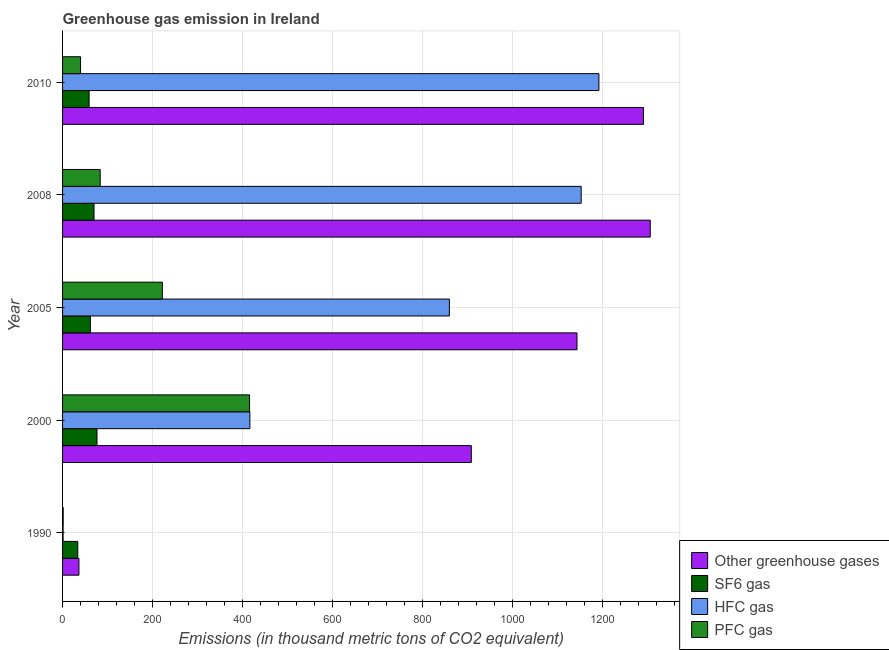How many groups of bars are there?
Your response must be concise. 5. How many bars are there on the 4th tick from the bottom?
Ensure brevity in your answer.  4. In how many cases, is the number of bars for a given year not equal to the number of legend labels?
Ensure brevity in your answer.  0. What is the emission of greenhouse gases in 2005?
Provide a short and direct response. 1143.3. Across all years, what is the maximum emission of greenhouse gases?
Keep it short and to the point. 1306.1. What is the total emission of greenhouse gases in the graph?
Your response must be concise. 4685.2. What is the difference between the emission of greenhouse gases in 2000 and that in 2010?
Provide a succinct answer. -382.6. What is the difference between the emission of hfc gas in 2010 and the emission of sf6 gas in 1990?
Offer a very short reply. 1158.2. What is the average emission of sf6 gas per year?
Keep it short and to the point. 60.2. In the year 2000, what is the difference between the emission of hfc gas and emission of greenhouse gases?
Your answer should be very brief. -492.1. In how many years, is the emission of pfc gas greater than 240 thousand metric tons?
Your answer should be compact. 1. What is the ratio of the emission of sf6 gas in 1990 to that in 2008?
Ensure brevity in your answer.  0.48. Is the emission of greenhouse gases in 1990 less than that in 2000?
Offer a very short reply. Yes. Is the difference between the emission of pfc gas in 2000 and 2010 greater than the difference between the emission of sf6 gas in 2000 and 2010?
Offer a very short reply. Yes. What is the difference between the highest and the lowest emission of sf6 gas?
Keep it short and to the point. 42.7. Is it the case that in every year, the sum of the emission of pfc gas and emission of hfc gas is greater than the sum of emission of sf6 gas and emission of greenhouse gases?
Your answer should be compact. No. What does the 2nd bar from the top in 1990 represents?
Provide a short and direct response. HFC gas. What does the 4th bar from the bottom in 2010 represents?
Ensure brevity in your answer.  PFC gas. How many years are there in the graph?
Make the answer very short. 5. Are the values on the major ticks of X-axis written in scientific E-notation?
Give a very brief answer. No. Where does the legend appear in the graph?
Give a very brief answer. Bottom right. How many legend labels are there?
Keep it short and to the point. 4. How are the legend labels stacked?
Make the answer very short. Vertical. What is the title of the graph?
Provide a short and direct response. Greenhouse gas emission in Ireland. What is the label or title of the X-axis?
Ensure brevity in your answer.  Emissions (in thousand metric tons of CO2 equivalent). What is the label or title of the Y-axis?
Offer a terse response. Year. What is the Emissions (in thousand metric tons of CO2 equivalent) in Other greenhouse gases in 1990?
Provide a succinct answer. 36.4. What is the Emissions (in thousand metric tons of CO2 equivalent) in SF6 gas in 1990?
Provide a short and direct response. 33.8. What is the Emissions (in thousand metric tons of CO2 equivalent) of Other greenhouse gases in 2000?
Provide a succinct answer. 908.4. What is the Emissions (in thousand metric tons of CO2 equivalent) of SF6 gas in 2000?
Provide a short and direct response. 76.5. What is the Emissions (in thousand metric tons of CO2 equivalent) of HFC gas in 2000?
Your answer should be compact. 416.3. What is the Emissions (in thousand metric tons of CO2 equivalent) in PFC gas in 2000?
Provide a succinct answer. 415.6. What is the Emissions (in thousand metric tons of CO2 equivalent) of Other greenhouse gases in 2005?
Keep it short and to the point. 1143.3. What is the Emissions (in thousand metric tons of CO2 equivalent) in SF6 gas in 2005?
Provide a succinct answer. 61.8. What is the Emissions (in thousand metric tons of CO2 equivalent) of HFC gas in 2005?
Your response must be concise. 859.7. What is the Emissions (in thousand metric tons of CO2 equivalent) of PFC gas in 2005?
Offer a very short reply. 221.8. What is the Emissions (in thousand metric tons of CO2 equivalent) in Other greenhouse gases in 2008?
Offer a very short reply. 1306.1. What is the Emissions (in thousand metric tons of CO2 equivalent) of SF6 gas in 2008?
Your answer should be compact. 69.9. What is the Emissions (in thousand metric tons of CO2 equivalent) of HFC gas in 2008?
Offer a very short reply. 1152.6. What is the Emissions (in thousand metric tons of CO2 equivalent) in PFC gas in 2008?
Offer a very short reply. 83.6. What is the Emissions (in thousand metric tons of CO2 equivalent) in Other greenhouse gases in 2010?
Your answer should be compact. 1291. What is the Emissions (in thousand metric tons of CO2 equivalent) in HFC gas in 2010?
Offer a terse response. 1192. Across all years, what is the maximum Emissions (in thousand metric tons of CO2 equivalent) of Other greenhouse gases?
Keep it short and to the point. 1306.1. Across all years, what is the maximum Emissions (in thousand metric tons of CO2 equivalent) in SF6 gas?
Ensure brevity in your answer.  76.5. Across all years, what is the maximum Emissions (in thousand metric tons of CO2 equivalent) of HFC gas?
Keep it short and to the point. 1192. Across all years, what is the maximum Emissions (in thousand metric tons of CO2 equivalent) in PFC gas?
Make the answer very short. 415.6. Across all years, what is the minimum Emissions (in thousand metric tons of CO2 equivalent) in Other greenhouse gases?
Your response must be concise. 36.4. Across all years, what is the minimum Emissions (in thousand metric tons of CO2 equivalent) of SF6 gas?
Your answer should be compact. 33.8. Across all years, what is the minimum Emissions (in thousand metric tons of CO2 equivalent) of HFC gas?
Make the answer very short. 1.2. Across all years, what is the minimum Emissions (in thousand metric tons of CO2 equivalent) in PFC gas?
Provide a short and direct response. 1.4. What is the total Emissions (in thousand metric tons of CO2 equivalent) of Other greenhouse gases in the graph?
Give a very brief answer. 4685.2. What is the total Emissions (in thousand metric tons of CO2 equivalent) of SF6 gas in the graph?
Your response must be concise. 301. What is the total Emissions (in thousand metric tons of CO2 equivalent) in HFC gas in the graph?
Provide a short and direct response. 3621.8. What is the total Emissions (in thousand metric tons of CO2 equivalent) in PFC gas in the graph?
Ensure brevity in your answer.  762.4. What is the difference between the Emissions (in thousand metric tons of CO2 equivalent) of Other greenhouse gases in 1990 and that in 2000?
Your answer should be compact. -872. What is the difference between the Emissions (in thousand metric tons of CO2 equivalent) of SF6 gas in 1990 and that in 2000?
Your response must be concise. -42.7. What is the difference between the Emissions (in thousand metric tons of CO2 equivalent) in HFC gas in 1990 and that in 2000?
Offer a terse response. -415.1. What is the difference between the Emissions (in thousand metric tons of CO2 equivalent) in PFC gas in 1990 and that in 2000?
Offer a terse response. -414.2. What is the difference between the Emissions (in thousand metric tons of CO2 equivalent) in Other greenhouse gases in 1990 and that in 2005?
Offer a very short reply. -1106.9. What is the difference between the Emissions (in thousand metric tons of CO2 equivalent) in SF6 gas in 1990 and that in 2005?
Ensure brevity in your answer.  -28. What is the difference between the Emissions (in thousand metric tons of CO2 equivalent) of HFC gas in 1990 and that in 2005?
Make the answer very short. -858.5. What is the difference between the Emissions (in thousand metric tons of CO2 equivalent) in PFC gas in 1990 and that in 2005?
Your answer should be compact. -220.4. What is the difference between the Emissions (in thousand metric tons of CO2 equivalent) in Other greenhouse gases in 1990 and that in 2008?
Offer a very short reply. -1269.7. What is the difference between the Emissions (in thousand metric tons of CO2 equivalent) in SF6 gas in 1990 and that in 2008?
Keep it short and to the point. -36.1. What is the difference between the Emissions (in thousand metric tons of CO2 equivalent) in HFC gas in 1990 and that in 2008?
Your response must be concise. -1151.4. What is the difference between the Emissions (in thousand metric tons of CO2 equivalent) of PFC gas in 1990 and that in 2008?
Give a very brief answer. -82.2. What is the difference between the Emissions (in thousand metric tons of CO2 equivalent) of Other greenhouse gases in 1990 and that in 2010?
Your answer should be very brief. -1254.6. What is the difference between the Emissions (in thousand metric tons of CO2 equivalent) in SF6 gas in 1990 and that in 2010?
Your answer should be compact. -25.2. What is the difference between the Emissions (in thousand metric tons of CO2 equivalent) in HFC gas in 1990 and that in 2010?
Offer a terse response. -1190.8. What is the difference between the Emissions (in thousand metric tons of CO2 equivalent) of PFC gas in 1990 and that in 2010?
Give a very brief answer. -38.6. What is the difference between the Emissions (in thousand metric tons of CO2 equivalent) in Other greenhouse gases in 2000 and that in 2005?
Provide a short and direct response. -234.9. What is the difference between the Emissions (in thousand metric tons of CO2 equivalent) in SF6 gas in 2000 and that in 2005?
Keep it short and to the point. 14.7. What is the difference between the Emissions (in thousand metric tons of CO2 equivalent) of HFC gas in 2000 and that in 2005?
Provide a succinct answer. -443.4. What is the difference between the Emissions (in thousand metric tons of CO2 equivalent) of PFC gas in 2000 and that in 2005?
Your answer should be very brief. 193.8. What is the difference between the Emissions (in thousand metric tons of CO2 equivalent) of Other greenhouse gases in 2000 and that in 2008?
Offer a very short reply. -397.7. What is the difference between the Emissions (in thousand metric tons of CO2 equivalent) in HFC gas in 2000 and that in 2008?
Provide a short and direct response. -736.3. What is the difference between the Emissions (in thousand metric tons of CO2 equivalent) in PFC gas in 2000 and that in 2008?
Offer a very short reply. 332. What is the difference between the Emissions (in thousand metric tons of CO2 equivalent) in Other greenhouse gases in 2000 and that in 2010?
Offer a terse response. -382.6. What is the difference between the Emissions (in thousand metric tons of CO2 equivalent) of SF6 gas in 2000 and that in 2010?
Provide a short and direct response. 17.5. What is the difference between the Emissions (in thousand metric tons of CO2 equivalent) of HFC gas in 2000 and that in 2010?
Keep it short and to the point. -775.7. What is the difference between the Emissions (in thousand metric tons of CO2 equivalent) of PFC gas in 2000 and that in 2010?
Provide a short and direct response. 375.6. What is the difference between the Emissions (in thousand metric tons of CO2 equivalent) in Other greenhouse gases in 2005 and that in 2008?
Your answer should be very brief. -162.8. What is the difference between the Emissions (in thousand metric tons of CO2 equivalent) in SF6 gas in 2005 and that in 2008?
Keep it short and to the point. -8.1. What is the difference between the Emissions (in thousand metric tons of CO2 equivalent) of HFC gas in 2005 and that in 2008?
Offer a terse response. -292.9. What is the difference between the Emissions (in thousand metric tons of CO2 equivalent) of PFC gas in 2005 and that in 2008?
Provide a short and direct response. 138.2. What is the difference between the Emissions (in thousand metric tons of CO2 equivalent) of Other greenhouse gases in 2005 and that in 2010?
Offer a very short reply. -147.7. What is the difference between the Emissions (in thousand metric tons of CO2 equivalent) in SF6 gas in 2005 and that in 2010?
Your response must be concise. 2.8. What is the difference between the Emissions (in thousand metric tons of CO2 equivalent) in HFC gas in 2005 and that in 2010?
Your answer should be very brief. -332.3. What is the difference between the Emissions (in thousand metric tons of CO2 equivalent) in PFC gas in 2005 and that in 2010?
Keep it short and to the point. 181.8. What is the difference between the Emissions (in thousand metric tons of CO2 equivalent) in HFC gas in 2008 and that in 2010?
Provide a succinct answer. -39.4. What is the difference between the Emissions (in thousand metric tons of CO2 equivalent) in PFC gas in 2008 and that in 2010?
Offer a terse response. 43.6. What is the difference between the Emissions (in thousand metric tons of CO2 equivalent) in Other greenhouse gases in 1990 and the Emissions (in thousand metric tons of CO2 equivalent) in SF6 gas in 2000?
Ensure brevity in your answer.  -40.1. What is the difference between the Emissions (in thousand metric tons of CO2 equivalent) in Other greenhouse gases in 1990 and the Emissions (in thousand metric tons of CO2 equivalent) in HFC gas in 2000?
Your answer should be very brief. -379.9. What is the difference between the Emissions (in thousand metric tons of CO2 equivalent) of Other greenhouse gases in 1990 and the Emissions (in thousand metric tons of CO2 equivalent) of PFC gas in 2000?
Make the answer very short. -379.2. What is the difference between the Emissions (in thousand metric tons of CO2 equivalent) in SF6 gas in 1990 and the Emissions (in thousand metric tons of CO2 equivalent) in HFC gas in 2000?
Provide a succinct answer. -382.5. What is the difference between the Emissions (in thousand metric tons of CO2 equivalent) in SF6 gas in 1990 and the Emissions (in thousand metric tons of CO2 equivalent) in PFC gas in 2000?
Give a very brief answer. -381.8. What is the difference between the Emissions (in thousand metric tons of CO2 equivalent) of HFC gas in 1990 and the Emissions (in thousand metric tons of CO2 equivalent) of PFC gas in 2000?
Ensure brevity in your answer.  -414.4. What is the difference between the Emissions (in thousand metric tons of CO2 equivalent) in Other greenhouse gases in 1990 and the Emissions (in thousand metric tons of CO2 equivalent) in SF6 gas in 2005?
Keep it short and to the point. -25.4. What is the difference between the Emissions (in thousand metric tons of CO2 equivalent) in Other greenhouse gases in 1990 and the Emissions (in thousand metric tons of CO2 equivalent) in HFC gas in 2005?
Ensure brevity in your answer.  -823.3. What is the difference between the Emissions (in thousand metric tons of CO2 equivalent) in Other greenhouse gases in 1990 and the Emissions (in thousand metric tons of CO2 equivalent) in PFC gas in 2005?
Your answer should be very brief. -185.4. What is the difference between the Emissions (in thousand metric tons of CO2 equivalent) of SF6 gas in 1990 and the Emissions (in thousand metric tons of CO2 equivalent) of HFC gas in 2005?
Keep it short and to the point. -825.9. What is the difference between the Emissions (in thousand metric tons of CO2 equivalent) in SF6 gas in 1990 and the Emissions (in thousand metric tons of CO2 equivalent) in PFC gas in 2005?
Provide a short and direct response. -188. What is the difference between the Emissions (in thousand metric tons of CO2 equivalent) in HFC gas in 1990 and the Emissions (in thousand metric tons of CO2 equivalent) in PFC gas in 2005?
Give a very brief answer. -220.6. What is the difference between the Emissions (in thousand metric tons of CO2 equivalent) of Other greenhouse gases in 1990 and the Emissions (in thousand metric tons of CO2 equivalent) of SF6 gas in 2008?
Ensure brevity in your answer.  -33.5. What is the difference between the Emissions (in thousand metric tons of CO2 equivalent) in Other greenhouse gases in 1990 and the Emissions (in thousand metric tons of CO2 equivalent) in HFC gas in 2008?
Your response must be concise. -1116.2. What is the difference between the Emissions (in thousand metric tons of CO2 equivalent) in Other greenhouse gases in 1990 and the Emissions (in thousand metric tons of CO2 equivalent) in PFC gas in 2008?
Provide a short and direct response. -47.2. What is the difference between the Emissions (in thousand metric tons of CO2 equivalent) of SF6 gas in 1990 and the Emissions (in thousand metric tons of CO2 equivalent) of HFC gas in 2008?
Your answer should be compact. -1118.8. What is the difference between the Emissions (in thousand metric tons of CO2 equivalent) in SF6 gas in 1990 and the Emissions (in thousand metric tons of CO2 equivalent) in PFC gas in 2008?
Provide a succinct answer. -49.8. What is the difference between the Emissions (in thousand metric tons of CO2 equivalent) in HFC gas in 1990 and the Emissions (in thousand metric tons of CO2 equivalent) in PFC gas in 2008?
Keep it short and to the point. -82.4. What is the difference between the Emissions (in thousand metric tons of CO2 equivalent) in Other greenhouse gases in 1990 and the Emissions (in thousand metric tons of CO2 equivalent) in SF6 gas in 2010?
Give a very brief answer. -22.6. What is the difference between the Emissions (in thousand metric tons of CO2 equivalent) in Other greenhouse gases in 1990 and the Emissions (in thousand metric tons of CO2 equivalent) in HFC gas in 2010?
Your answer should be compact. -1155.6. What is the difference between the Emissions (in thousand metric tons of CO2 equivalent) in SF6 gas in 1990 and the Emissions (in thousand metric tons of CO2 equivalent) in HFC gas in 2010?
Offer a very short reply. -1158.2. What is the difference between the Emissions (in thousand metric tons of CO2 equivalent) in HFC gas in 1990 and the Emissions (in thousand metric tons of CO2 equivalent) in PFC gas in 2010?
Make the answer very short. -38.8. What is the difference between the Emissions (in thousand metric tons of CO2 equivalent) in Other greenhouse gases in 2000 and the Emissions (in thousand metric tons of CO2 equivalent) in SF6 gas in 2005?
Make the answer very short. 846.6. What is the difference between the Emissions (in thousand metric tons of CO2 equivalent) of Other greenhouse gases in 2000 and the Emissions (in thousand metric tons of CO2 equivalent) of HFC gas in 2005?
Make the answer very short. 48.7. What is the difference between the Emissions (in thousand metric tons of CO2 equivalent) of Other greenhouse gases in 2000 and the Emissions (in thousand metric tons of CO2 equivalent) of PFC gas in 2005?
Offer a very short reply. 686.6. What is the difference between the Emissions (in thousand metric tons of CO2 equivalent) of SF6 gas in 2000 and the Emissions (in thousand metric tons of CO2 equivalent) of HFC gas in 2005?
Your answer should be compact. -783.2. What is the difference between the Emissions (in thousand metric tons of CO2 equivalent) in SF6 gas in 2000 and the Emissions (in thousand metric tons of CO2 equivalent) in PFC gas in 2005?
Offer a terse response. -145.3. What is the difference between the Emissions (in thousand metric tons of CO2 equivalent) in HFC gas in 2000 and the Emissions (in thousand metric tons of CO2 equivalent) in PFC gas in 2005?
Your answer should be compact. 194.5. What is the difference between the Emissions (in thousand metric tons of CO2 equivalent) of Other greenhouse gases in 2000 and the Emissions (in thousand metric tons of CO2 equivalent) of SF6 gas in 2008?
Give a very brief answer. 838.5. What is the difference between the Emissions (in thousand metric tons of CO2 equivalent) of Other greenhouse gases in 2000 and the Emissions (in thousand metric tons of CO2 equivalent) of HFC gas in 2008?
Offer a very short reply. -244.2. What is the difference between the Emissions (in thousand metric tons of CO2 equivalent) in Other greenhouse gases in 2000 and the Emissions (in thousand metric tons of CO2 equivalent) in PFC gas in 2008?
Your response must be concise. 824.8. What is the difference between the Emissions (in thousand metric tons of CO2 equivalent) in SF6 gas in 2000 and the Emissions (in thousand metric tons of CO2 equivalent) in HFC gas in 2008?
Offer a terse response. -1076.1. What is the difference between the Emissions (in thousand metric tons of CO2 equivalent) in HFC gas in 2000 and the Emissions (in thousand metric tons of CO2 equivalent) in PFC gas in 2008?
Make the answer very short. 332.7. What is the difference between the Emissions (in thousand metric tons of CO2 equivalent) in Other greenhouse gases in 2000 and the Emissions (in thousand metric tons of CO2 equivalent) in SF6 gas in 2010?
Make the answer very short. 849.4. What is the difference between the Emissions (in thousand metric tons of CO2 equivalent) in Other greenhouse gases in 2000 and the Emissions (in thousand metric tons of CO2 equivalent) in HFC gas in 2010?
Your answer should be very brief. -283.6. What is the difference between the Emissions (in thousand metric tons of CO2 equivalent) in Other greenhouse gases in 2000 and the Emissions (in thousand metric tons of CO2 equivalent) in PFC gas in 2010?
Give a very brief answer. 868.4. What is the difference between the Emissions (in thousand metric tons of CO2 equivalent) in SF6 gas in 2000 and the Emissions (in thousand metric tons of CO2 equivalent) in HFC gas in 2010?
Ensure brevity in your answer.  -1115.5. What is the difference between the Emissions (in thousand metric tons of CO2 equivalent) of SF6 gas in 2000 and the Emissions (in thousand metric tons of CO2 equivalent) of PFC gas in 2010?
Give a very brief answer. 36.5. What is the difference between the Emissions (in thousand metric tons of CO2 equivalent) of HFC gas in 2000 and the Emissions (in thousand metric tons of CO2 equivalent) of PFC gas in 2010?
Make the answer very short. 376.3. What is the difference between the Emissions (in thousand metric tons of CO2 equivalent) of Other greenhouse gases in 2005 and the Emissions (in thousand metric tons of CO2 equivalent) of SF6 gas in 2008?
Your answer should be compact. 1073.4. What is the difference between the Emissions (in thousand metric tons of CO2 equivalent) of Other greenhouse gases in 2005 and the Emissions (in thousand metric tons of CO2 equivalent) of PFC gas in 2008?
Make the answer very short. 1059.7. What is the difference between the Emissions (in thousand metric tons of CO2 equivalent) of SF6 gas in 2005 and the Emissions (in thousand metric tons of CO2 equivalent) of HFC gas in 2008?
Your answer should be compact. -1090.8. What is the difference between the Emissions (in thousand metric tons of CO2 equivalent) of SF6 gas in 2005 and the Emissions (in thousand metric tons of CO2 equivalent) of PFC gas in 2008?
Offer a terse response. -21.8. What is the difference between the Emissions (in thousand metric tons of CO2 equivalent) in HFC gas in 2005 and the Emissions (in thousand metric tons of CO2 equivalent) in PFC gas in 2008?
Your answer should be very brief. 776.1. What is the difference between the Emissions (in thousand metric tons of CO2 equivalent) of Other greenhouse gases in 2005 and the Emissions (in thousand metric tons of CO2 equivalent) of SF6 gas in 2010?
Your response must be concise. 1084.3. What is the difference between the Emissions (in thousand metric tons of CO2 equivalent) of Other greenhouse gases in 2005 and the Emissions (in thousand metric tons of CO2 equivalent) of HFC gas in 2010?
Give a very brief answer. -48.7. What is the difference between the Emissions (in thousand metric tons of CO2 equivalent) in Other greenhouse gases in 2005 and the Emissions (in thousand metric tons of CO2 equivalent) in PFC gas in 2010?
Your answer should be compact. 1103.3. What is the difference between the Emissions (in thousand metric tons of CO2 equivalent) in SF6 gas in 2005 and the Emissions (in thousand metric tons of CO2 equivalent) in HFC gas in 2010?
Provide a short and direct response. -1130.2. What is the difference between the Emissions (in thousand metric tons of CO2 equivalent) in SF6 gas in 2005 and the Emissions (in thousand metric tons of CO2 equivalent) in PFC gas in 2010?
Provide a short and direct response. 21.8. What is the difference between the Emissions (in thousand metric tons of CO2 equivalent) in HFC gas in 2005 and the Emissions (in thousand metric tons of CO2 equivalent) in PFC gas in 2010?
Give a very brief answer. 819.7. What is the difference between the Emissions (in thousand metric tons of CO2 equivalent) of Other greenhouse gases in 2008 and the Emissions (in thousand metric tons of CO2 equivalent) of SF6 gas in 2010?
Offer a terse response. 1247.1. What is the difference between the Emissions (in thousand metric tons of CO2 equivalent) in Other greenhouse gases in 2008 and the Emissions (in thousand metric tons of CO2 equivalent) in HFC gas in 2010?
Offer a very short reply. 114.1. What is the difference between the Emissions (in thousand metric tons of CO2 equivalent) in Other greenhouse gases in 2008 and the Emissions (in thousand metric tons of CO2 equivalent) in PFC gas in 2010?
Keep it short and to the point. 1266.1. What is the difference between the Emissions (in thousand metric tons of CO2 equivalent) of SF6 gas in 2008 and the Emissions (in thousand metric tons of CO2 equivalent) of HFC gas in 2010?
Ensure brevity in your answer.  -1122.1. What is the difference between the Emissions (in thousand metric tons of CO2 equivalent) in SF6 gas in 2008 and the Emissions (in thousand metric tons of CO2 equivalent) in PFC gas in 2010?
Provide a succinct answer. 29.9. What is the difference between the Emissions (in thousand metric tons of CO2 equivalent) of HFC gas in 2008 and the Emissions (in thousand metric tons of CO2 equivalent) of PFC gas in 2010?
Your response must be concise. 1112.6. What is the average Emissions (in thousand metric tons of CO2 equivalent) in Other greenhouse gases per year?
Offer a very short reply. 937.04. What is the average Emissions (in thousand metric tons of CO2 equivalent) of SF6 gas per year?
Provide a short and direct response. 60.2. What is the average Emissions (in thousand metric tons of CO2 equivalent) in HFC gas per year?
Offer a terse response. 724.36. What is the average Emissions (in thousand metric tons of CO2 equivalent) of PFC gas per year?
Provide a succinct answer. 152.48. In the year 1990, what is the difference between the Emissions (in thousand metric tons of CO2 equivalent) in Other greenhouse gases and Emissions (in thousand metric tons of CO2 equivalent) in SF6 gas?
Your answer should be very brief. 2.6. In the year 1990, what is the difference between the Emissions (in thousand metric tons of CO2 equivalent) in Other greenhouse gases and Emissions (in thousand metric tons of CO2 equivalent) in HFC gas?
Keep it short and to the point. 35.2. In the year 1990, what is the difference between the Emissions (in thousand metric tons of CO2 equivalent) in SF6 gas and Emissions (in thousand metric tons of CO2 equivalent) in HFC gas?
Keep it short and to the point. 32.6. In the year 1990, what is the difference between the Emissions (in thousand metric tons of CO2 equivalent) in SF6 gas and Emissions (in thousand metric tons of CO2 equivalent) in PFC gas?
Give a very brief answer. 32.4. In the year 2000, what is the difference between the Emissions (in thousand metric tons of CO2 equivalent) of Other greenhouse gases and Emissions (in thousand metric tons of CO2 equivalent) of SF6 gas?
Keep it short and to the point. 831.9. In the year 2000, what is the difference between the Emissions (in thousand metric tons of CO2 equivalent) of Other greenhouse gases and Emissions (in thousand metric tons of CO2 equivalent) of HFC gas?
Offer a terse response. 492.1. In the year 2000, what is the difference between the Emissions (in thousand metric tons of CO2 equivalent) in Other greenhouse gases and Emissions (in thousand metric tons of CO2 equivalent) in PFC gas?
Offer a terse response. 492.8. In the year 2000, what is the difference between the Emissions (in thousand metric tons of CO2 equivalent) of SF6 gas and Emissions (in thousand metric tons of CO2 equivalent) of HFC gas?
Your response must be concise. -339.8. In the year 2000, what is the difference between the Emissions (in thousand metric tons of CO2 equivalent) of SF6 gas and Emissions (in thousand metric tons of CO2 equivalent) of PFC gas?
Give a very brief answer. -339.1. In the year 2005, what is the difference between the Emissions (in thousand metric tons of CO2 equivalent) of Other greenhouse gases and Emissions (in thousand metric tons of CO2 equivalent) of SF6 gas?
Make the answer very short. 1081.5. In the year 2005, what is the difference between the Emissions (in thousand metric tons of CO2 equivalent) of Other greenhouse gases and Emissions (in thousand metric tons of CO2 equivalent) of HFC gas?
Your answer should be very brief. 283.6. In the year 2005, what is the difference between the Emissions (in thousand metric tons of CO2 equivalent) in Other greenhouse gases and Emissions (in thousand metric tons of CO2 equivalent) in PFC gas?
Keep it short and to the point. 921.5. In the year 2005, what is the difference between the Emissions (in thousand metric tons of CO2 equivalent) in SF6 gas and Emissions (in thousand metric tons of CO2 equivalent) in HFC gas?
Your response must be concise. -797.9. In the year 2005, what is the difference between the Emissions (in thousand metric tons of CO2 equivalent) of SF6 gas and Emissions (in thousand metric tons of CO2 equivalent) of PFC gas?
Offer a very short reply. -160. In the year 2005, what is the difference between the Emissions (in thousand metric tons of CO2 equivalent) of HFC gas and Emissions (in thousand metric tons of CO2 equivalent) of PFC gas?
Keep it short and to the point. 637.9. In the year 2008, what is the difference between the Emissions (in thousand metric tons of CO2 equivalent) in Other greenhouse gases and Emissions (in thousand metric tons of CO2 equivalent) in SF6 gas?
Ensure brevity in your answer.  1236.2. In the year 2008, what is the difference between the Emissions (in thousand metric tons of CO2 equivalent) in Other greenhouse gases and Emissions (in thousand metric tons of CO2 equivalent) in HFC gas?
Ensure brevity in your answer.  153.5. In the year 2008, what is the difference between the Emissions (in thousand metric tons of CO2 equivalent) of Other greenhouse gases and Emissions (in thousand metric tons of CO2 equivalent) of PFC gas?
Your answer should be very brief. 1222.5. In the year 2008, what is the difference between the Emissions (in thousand metric tons of CO2 equivalent) of SF6 gas and Emissions (in thousand metric tons of CO2 equivalent) of HFC gas?
Provide a short and direct response. -1082.7. In the year 2008, what is the difference between the Emissions (in thousand metric tons of CO2 equivalent) in SF6 gas and Emissions (in thousand metric tons of CO2 equivalent) in PFC gas?
Your response must be concise. -13.7. In the year 2008, what is the difference between the Emissions (in thousand metric tons of CO2 equivalent) of HFC gas and Emissions (in thousand metric tons of CO2 equivalent) of PFC gas?
Give a very brief answer. 1069. In the year 2010, what is the difference between the Emissions (in thousand metric tons of CO2 equivalent) of Other greenhouse gases and Emissions (in thousand metric tons of CO2 equivalent) of SF6 gas?
Give a very brief answer. 1232. In the year 2010, what is the difference between the Emissions (in thousand metric tons of CO2 equivalent) of Other greenhouse gases and Emissions (in thousand metric tons of CO2 equivalent) of HFC gas?
Offer a very short reply. 99. In the year 2010, what is the difference between the Emissions (in thousand metric tons of CO2 equivalent) of Other greenhouse gases and Emissions (in thousand metric tons of CO2 equivalent) of PFC gas?
Your answer should be compact. 1251. In the year 2010, what is the difference between the Emissions (in thousand metric tons of CO2 equivalent) in SF6 gas and Emissions (in thousand metric tons of CO2 equivalent) in HFC gas?
Make the answer very short. -1133. In the year 2010, what is the difference between the Emissions (in thousand metric tons of CO2 equivalent) of SF6 gas and Emissions (in thousand metric tons of CO2 equivalent) of PFC gas?
Keep it short and to the point. 19. In the year 2010, what is the difference between the Emissions (in thousand metric tons of CO2 equivalent) of HFC gas and Emissions (in thousand metric tons of CO2 equivalent) of PFC gas?
Make the answer very short. 1152. What is the ratio of the Emissions (in thousand metric tons of CO2 equivalent) in Other greenhouse gases in 1990 to that in 2000?
Ensure brevity in your answer.  0.04. What is the ratio of the Emissions (in thousand metric tons of CO2 equivalent) in SF6 gas in 1990 to that in 2000?
Ensure brevity in your answer.  0.44. What is the ratio of the Emissions (in thousand metric tons of CO2 equivalent) in HFC gas in 1990 to that in 2000?
Keep it short and to the point. 0. What is the ratio of the Emissions (in thousand metric tons of CO2 equivalent) of PFC gas in 1990 to that in 2000?
Your answer should be compact. 0. What is the ratio of the Emissions (in thousand metric tons of CO2 equivalent) of Other greenhouse gases in 1990 to that in 2005?
Your answer should be very brief. 0.03. What is the ratio of the Emissions (in thousand metric tons of CO2 equivalent) of SF6 gas in 1990 to that in 2005?
Offer a very short reply. 0.55. What is the ratio of the Emissions (in thousand metric tons of CO2 equivalent) in HFC gas in 1990 to that in 2005?
Your answer should be compact. 0. What is the ratio of the Emissions (in thousand metric tons of CO2 equivalent) of PFC gas in 1990 to that in 2005?
Offer a very short reply. 0.01. What is the ratio of the Emissions (in thousand metric tons of CO2 equivalent) of Other greenhouse gases in 1990 to that in 2008?
Make the answer very short. 0.03. What is the ratio of the Emissions (in thousand metric tons of CO2 equivalent) in SF6 gas in 1990 to that in 2008?
Offer a very short reply. 0.48. What is the ratio of the Emissions (in thousand metric tons of CO2 equivalent) in HFC gas in 1990 to that in 2008?
Give a very brief answer. 0. What is the ratio of the Emissions (in thousand metric tons of CO2 equivalent) in PFC gas in 1990 to that in 2008?
Your answer should be very brief. 0.02. What is the ratio of the Emissions (in thousand metric tons of CO2 equivalent) of Other greenhouse gases in 1990 to that in 2010?
Offer a very short reply. 0.03. What is the ratio of the Emissions (in thousand metric tons of CO2 equivalent) of SF6 gas in 1990 to that in 2010?
Give a very brief answer. 0.57. What is the ratio of the Emissions (in thousand metric tons of CO2 equivalent) of PFC gas in 1990 to that in 2010?
Provide a succinct answer. 0.04. What is the ratio of the Emissions (in thousand metric tons of CO2 equivalent) of Other greenhouse gases in 2000 to that in 2005?
Provide a succinct answer. 0.79. What is the ratio of the Emissions (in thousand metric tons of CO2 equivalent) of SF6 gas in 2000 to that in 2005?
Keep it short and to the point. 1.24. What is the ratio of the Emissions (in thousand metric tons of CO2 equivalent) of HFC gas in 2000 to that in 2005?
Give a very brief answer. 0.48. What is the ratio of the Emissions (in thousand metric tons of CO2 equivalent) of PFC gas in 2000 to that in 2005?
Keep it short and to the point. 1.87. What is the ratio of the Emissions (in thousand metric tons of CO2 equivalent) in Other greenhouse gases in 2000 to that in 2008?
Your response must be concise. 0.7. What is the ratio of the Emissions (in thousand metric tons of CO2 equivalent) in SF6 gas in 2000 to that in 2008?
Offer a very short reply. 1.09. What is the ratio of the Emissions (in thousand metric tons of CO2 equivalent) of HFC gas in 2000 to that in 2008?
Give a very brief answer. 0.36. What is the ratio of the Emissions (in thousand metric tons of CO2 equivalent) of PFC gas in 2000 to that in 2008?
Offer a very short reply. 4.97. What is the ratio of the Emissions (in thousand metric tons of CO2 equivalent) of Other greenhouse gases in 2000 to that in 2010?
Provide a succinct answer. 0.7. What is the ratio of the Emissions (in thousand metric tons of CO2 equivalent) in SF6 gas in 2000 to that in 2010?
Ensure brevity in your answer.  1.3. What is the ratio of the Emissions (in thousand metric tons of CO2 equivalent) in HFC gas in 2000 to that in 2010?
Your answer should be very brief. 0.35. What is the ratio of the Emissions (in thousand metric tons of CO2 equivalent) of PFC gas in 2000 to that in 2010?
Make the answer very short. 10.39. What is the ratio of the Emissions (in thousand metric tons of CO2 equivalent) in Other greenhouse gases in 2005 to that in 2008?
Offer a very short reply. 0.88. What is the ratio of the Emissions (in thousand metric tons of CO2 equivalent) in SF6 gas in 2005 to that in 2008?
Your answer should be compact. 0.88. What is the ratio of the Emissions (in thousand metric tons of CO2 equivalent) in HFC gas in 2005 to that in 2008?
Ensure brevity in your answer.  0.75. What is the ratio of the Emissions (in thousand metric tons of CO2 equivalent) in PFC gas in 2005 to that in 2008?
Your answer should be very brief. 2.65. What is the ratio of the Emissions (in thousand metric tons of CO2 equivalent) of Other greenhouse gases in 2005 to that in 2010?
Your answer should be very brief. 0.89. What is the ratio of the Emissions (in thousand metric tons of CO2 equivalent) in SF6 gas in 2005 to that in 2010?
Your answer should be very brief. 1.05. What is the ratio of the Emissions (in thousand metric tons of CO2 equivalent) of HFC gas in 2005 to that in 2010?
Offer a very short reply. 0.72. What is the ratio of the Emissions (in thousand metric tons of CO2 equivalent) of PFC gas in 2005 to that in 2010?
Provide a short and direct response. 5.54. What is the ratio of the Emissions (in thousand metric tons of CO2 equivalent) of Other greenhouse gases in 2008 to that in 2010?
Give a very brief answer. 1.01. What is the ratio of the Emissions (in thousand metric tons of CO2 equivalent) in SF6 gas in 2008 to that in 2010?
Your response must be concise. 1.18. What is the ratio of the Emissions (in thousand metric tons of CO2 equivalent) of HFC gas in 2008 to that in 2010?
Ensure brevity in your answer.  0.97. What is the ratio of the Emissions (in thousand metric tons of CO2 equivalent) of PFC gas in 2008 to that in 2010?
Provide a short and direct response. 2.09. What is the difference between the highest and the second highest Emissions (in thousand metric tons of CO2 equivalent) in SF6 gas?
Make the answer very short. 6.6. What is the difference between the highest and the second highest Emissions (in thousand metric tons of CO2 equivalent) in HFC gas?
Ensure brevity in your answer.  39.4. What is the difference between the highest and the second highest Emissions (in thousand metric tons of CO2 equivalent) in PFC gas?
Ensure brevity in your answer.  193.8. What is the difference between the highest and the lowest Emissions (in thousand metric tons of CO2 equivalent) in Other greenhouse gases?
Make the answer very short. 1269.7. What is the difference between the highest and the lowest Emissions (in thousand metric tons of CO2 equivalent) in SF6 gas?
Offer a very short reply. 42.7. What is the difference between the highest and the lowest Emissions (in thousand metric tons of CO2 equivalent) in HFC gas?
Offer a very short reply. 1190.8. What is the difference between the highest and the lowest Emissions (in thousand metric tons of CO2 equivalent) of PFC gas?
Give a very brief answer. 414.2. 